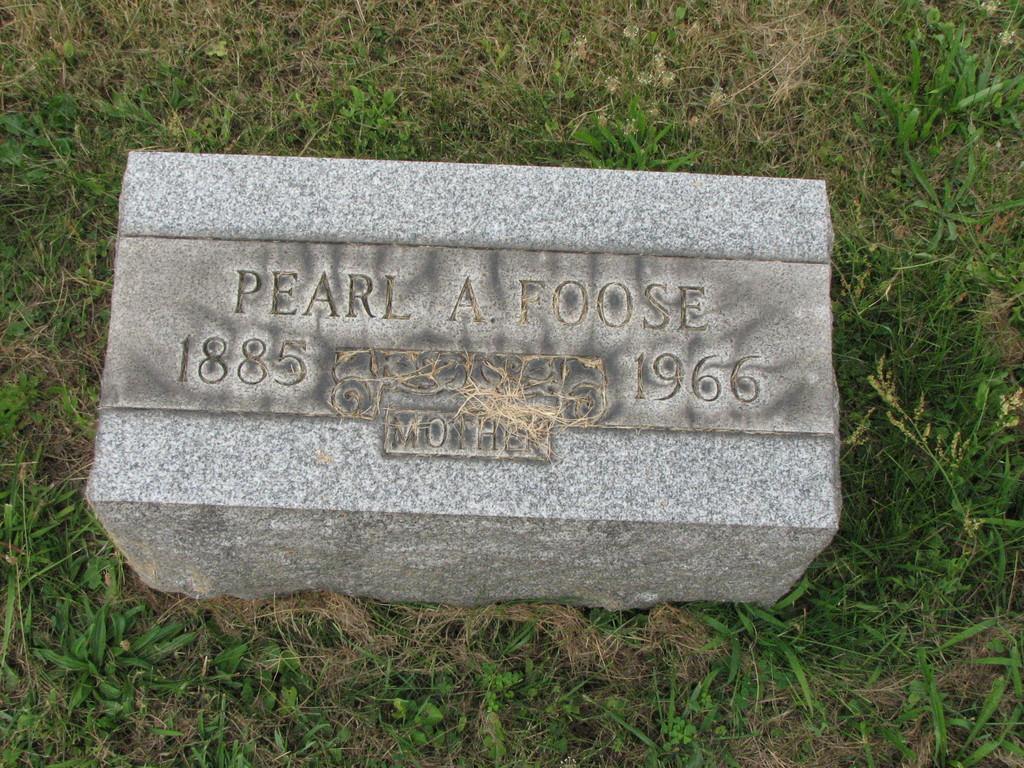Can you describe this image briefly? We can see stone on the grass and we can see some information on this stone. 